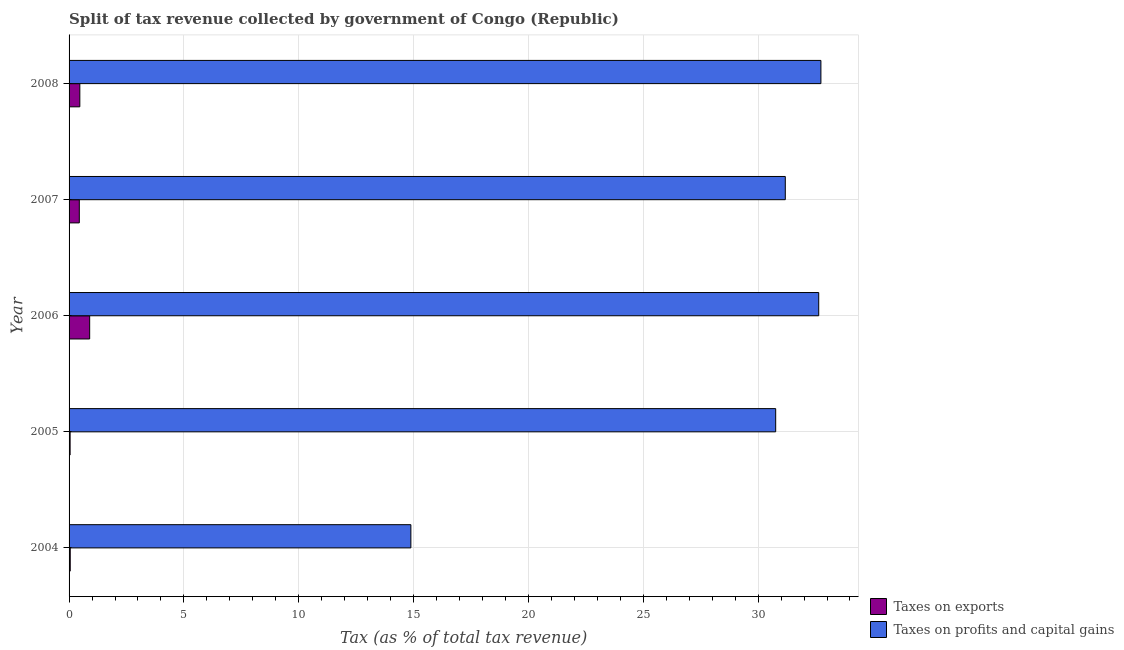How many different coloured bars are there?
Offer a very short reply. 2. Are the number of bars per tick equal to the number of legend labels?
Offer a very short reply. Yes. How many bars are there on the 4th tick from the bottom?
Provide a succinct answer. 2. What is the label of the 5th group of bars from the top?
Your response must be concise. 2004. In how many cases, is the number of bars for a given year not equal to the number of legend labels?
Offer a terse response. 0. What is the percentage of revenue obtained from taxes on exports in 2007?
Your answer should be very brief. 0.45. Across all years, what is the maximum percentage of revenue obtained from taxes on exports?
Provide a short and direct response. 0.9. Across all years, what is the minimum percentage of revenue obtained from taxes on profits and capital gains?
Offer a very short reply. 14.88. In which year was the percentage of revenue obtained from taxes on exports minimum?
Your answer should be very brief. 2005. What is the total percentage of revenue obtained from taxes on exports in the graph?
Your answer should be very brief. 1.91. What is the difference between the percentage of revenue obtained from taxes on profits and capital gains in 2005 and that in 2007?
Offer a terse response. -0.42. What is the difference between the percentage of revenue obtained from taxes on exports in 2007 and the percentage of revenue obtained from taxes on profits and capital gains in 2004?
Offer a very short reply. -14.44. What is the average percentage of revenue obtained from taxes on exports per year?
Give a very brief answer. 0.38. In the year 2004, what is the difference between the percentage of revenue obtained from taxes on profits and capital gains and percentage of revenue obtained from taxes on exports?
Make the answer very short. 14.83. What is the ratio of the percentage of revenue obtained from taxes on profits and capital gains in 2004 to that in 2007?
Offer a terse response. 0.48. What is the difference between the highest and the second highest percentage of revenue obtained from taxes on profits and capital gains?
Give a very brief answer. 0.1. What is the difference between the highest and the lowest percentage of revenue obtained from taxes on profits and capital gains?
Your answer should be very brief. 17.85. Is the sum of the percentage of revenue obtained from taxes on profits and capital gains in 2007 and 2008 greater than the maximum percentage of revenue obtained from taxes on exports across all years?
Keep it short and to the point. Yes. What does the 2nd bar from the top in 2006 represents?
Offer a very short reply. Taxes on exports. What does the 1st bar from the bottom in 2005 represents?
Offer a very short reply. Taxes on exports. What is the difference between two consecutive major ticks on the X-axis?
Ensure brevity in your answer.  5. Where does the legend appear in the graph?
Make the answer very short. Bottom right. How are the legend labels stacked?
Your response must be concise. Vertical. What is the title of the graph?
Your answer should be compact. Split of tax revenue collected by government of Congo (Republic). Does "Private funds" appear as one of the legend labels in the graph?
Make the answer very short. No. What is the label or title of the X-axis?
Offer a terse response. Tax (as % of total tax revenue). What is the label or title of the Y-axis?
Ensure brevity in your answer.  Year. What is the Tax (as % of total tax revenue) of Taxes on exports in 2004?
Your response must be concise. 0.05. What is the Tax (as % of total tax revenue) in Taxes on profits and capital gains in 2004?
Keep it short and to the point. 14.88. What is the Tax (as % of total tax revenue) of Taxes on exports in 2005?
Offer a terse response. 0.05. What is the Tax (as % of total tax revenue) of Taxes on profits and capital gains in 2005?
Offer a terse response. 30.77. What is the Tax (as % of total tax revenue) of Taxes on exports in 2006?
Give a very brief answer. 0.9. What is the Tax (as % of total tax revenue) of Taxes on profits and capital gains in 2006?
Provide a short and direct response. 32.64. What is the Tax (as % of total tax revenue) of Taxes on exports in 2007?
Offer a terse response. 0.45. What is the Tax (as % of total tax revenue) in Taxes on profits and capital gains in 2007?
Provide a short and direct response. 31.18. What is the Tax (as % of total tax revenue) in Taxes on exports in 2008?
Your answer should be very brief. 0.47. What is the Tax (as % of total tax revenue) in Taxes on profits and capital gains in 2008?
Provide a succinct answer. 32.73. Across all years, what is the maximum Tax (as % of total tax revenue) in Taxes on exports?
Your response must be concise. 0.9. Across all years, what is the maximum Tax (as % of total tax revenue) of Taxes on profits and capital gains?
Provide a short and direct response. 32.73. Across all years, what is the minimum Tax (as % of total tax revenue) of Taxes on exports?
Ensure brevity in your answer.  0.05. Across all years, what is the minimum Tax (as % of total tax revenue) of Taxes on profits and capital gains?
Ensure brevity in your answer.  14.88. What is the total Tax (as % of total tax revenue) of Taxes on exports in the graph?
Ensure brevity in your answer.  1.91. What is the total Tax (as % of total tax revenue) in Taxes on profits and capital gains in the graph?
Your answer should be very brief. 142.2. What is the difference between the Tax (as % of total tax revenue) of Taxes on exports in 2004 and that in 2005?
Your answer should be compact. 0.01. What is the difference between the Tax (as % of total tax revenue) of Taxes on profits and capital gains in 2004 and that in 2005?
Offer a very short reply. -15.88. What is the difference between the Tax (as % of total tax revenue) in Taxes on exports in 2004 and that in 2006?
Give a very brief answer. -0.85. What is the difference between the Tax (as % of total tax revenue) in Taxes on profits and capital gains in 2004 and that in 2006?
Keep it short and to the point. -17.76. What is the difference between the Tax (as % of total tax revenue) in Taxes on exports in 2004 and that in 2007?
Keep it short and to the point. -0.4. What is the difference between the Tax (as % of total tax revenue) of Taxes on profits and capital gains in 2004 and that in 2007?
Ensure brevity in your answer.  -16.3. What is the difference between the Tax (as % of total tax revenue) of Taxes on exports in 2004 and that in 2008?
Make the answer very short. -0.42. What is the difference between the Tax (as % of total tax revenue) in Taxes on profits and capital gains in 2004 and that in 2008?
Provide a succinct answer. -17.85. What is the difference between the Tax (as % of total tax revenue) of Taxes on exports in 2005 and that in 2006?
Your answer should be very brief. -0.85. What is the difference between the Tax (as % of total tax revenue) of Taxes on profits and capital gains in 2005 and that in 2006?
Your response must be concise. -1.87. What is the difference between the Tax (as % of total tax revenue) in Taxes on exports in 2005 and that in 2007?
Your answer should be very brief. -0.4. What is the difference between the Tax (as % of total tax revenue) in Taxes on profits and capital gains in 2005 and that in 2007?
Provide a short and direct response. -0.42. What is the difference between the Tax (as % of total tax revenue) of Taxes on exports in 2005 and that in 2008?
Provide a short and direct response. -0.42. What is the difference between the Tax (as % of total tax revenue) of Taxes on profits and capital gains in 2005 and that in 2008?
Offer a very short reply. -1.97. What is the difference between the Tax (as % of total tax revenue) in Taxes on exports in 2006 and that in 2007?
Give a very brief answer. 0.45. What is the difference between the Tax (as % of total tax revenue) of Taxes on profits and capital gains in 2006 and that in 2007?
Make the answer very short. 1.46. What is the difference between the Tax (as % of total tax revenue) of Taxes on exports in 2006 and that in 2008?
Provide a succinct answer. 0.43. What is the difference between the Tax (as % of total tax revenue) in Taxes on profits and capital gains in 2006 and that in 2008?
Provide a succinct answer. -0.09. What is the difference between the Tax (as % of total tax revenue) in Taxes on exports in 2007 and that in 2008?
Your response must be concise. -0.02. What is the difference between the Tax (as % of total tax revenue) of Taxes on profits and capital gains in 2007 and that in 2008?
Offer a terse response. -1.55. What is the difference between the Tax (as % of total tax revenue) of Taxes on exports in 2004 and the Tax (as % of total tax revenue) of Taxes on profits and capital gains in 2005?
Offer a terse response. -30.71. What is the difference between the Tax (as % of total tax revenue) in Taxes on exports in 2004 and the Tax (as % of total tax revenue) in Taxes on profits and capital gains in 2006?
Your answer should be very brief. -32.59. What is the difference between the Tax (as % of total tax revenue) in Taxes on exports in 2004 and the Tax (as % of total tax revenue) in Taxes on profits and capital gains in 2007?
Your response must be concise. -31.13. What is the difference between the Tax (as % of total tax revenue) in Taxes on exports in 2004 and the Tax (as % of total tax revenue) in Taxes on profits and capital gains in 2008?
Your answer should be compact. -32.68. What is the difference between the Tax (as % of total tax revenue) of Taxes on exports in 2005 and the Tax (as % of total tax revenue) of Taxes on profits and capital gains in 2006?
Keep it short and to the point. -32.59. What is the difference between the Tax (as % of total tax revenue) of Taxes on exports in 2005 and the Tax (as % of total tax revenue) of Taxes on profits and capital gains in 2007?
Ensure brevity in your answer.  -31.14. What is the difference between the Tax (as % of total tax revenue) in Taxes on exports in 2005 and the Tax (as % of total tax revenue) in Taxes on profits and capital gains in 2008?
Make the answer very short. -32.69. What is the difference between the Tax (as % of total tax revenue) of Taxes on exports in 2006 and the Tax (as % of total tax revenue) of Taxes on profits and capital gains in 2007?
Make the answer very short. -30.29. What is the difference between the Tax (as % of total tax revenue) of Taxes on exports in 2006 and the Tax (as % of total tax revenue) of Taxes on profits and capital gains in 2008?
Your answer should be very brief. -31.84. What is the difference between the Tax (as % of total tax revenue) of Taxes on exports in 2007 and the Tax (as % of total tax revenue) of Taxes on profits and capital gains in 2008?
Your answer should be very brief. -32.29. What is the average Tax (as % of total tax revenue) in Taxes on exports per year?
Offer a very short reply. 0.38. What is the average Tax (as % of total tax revenue) of Taxes on profits and capital gains per year?
Provide a short and direct response. 28.44. In the year 2004, what is the difference between the Tax (as % of total tax revenue) in Taxes on exports and Tax (as % of total tax revenue) in Taxes on profits and capital gains?
Give a very brief answer. -14.83. In the year 2005, what is the difference between the Tax (as % of total tax revenue) of Taxes on exports and Tax (as % of total tax revenue) of Taxes on profits and capital gains?
Provide a short and direct response. -30.72. In the year 2006, what is the difference between the Tax (as % of total tax revenue) in Taxes on exports and Tax (as % of total tax revenue) in Taxes on profits and capital gains?
Provide a short and direct response. -31.74. In the year 2007, what is the difference between the Tax (as % of total tax revenue) of Taxes on exports and Tax (as % of total tax revenue) of Taxes on profits and capital gains?
Ensure brevity in your answer.  -30.74. In the year 2008, what is the difference between the Tax (as % of total tax revenue) in Taxes on exports and Tax (as % of total tax revenue) in Taxes on profits and capital gains?
Your answer should be very brief. -32.27. What is the ratio of the Tax (as % of total tax revenue) of Taxes on exports in 2004 to that in 2005?
Make the answer very short. 1.11. What is the ratio of the Tax (as % of total tax revenue) in Taxes on profits and capital gains in 2004 to that in 2005?
Offer a very short reply. 0.48. What is the ratio of the Tax (as % of total tax revenue) of Taxes on exports in 2004 to that in 2006?
Your answer should be very brief. 0.06. What is the ratio of the Tax (as % of total tax revenue) of Taxes on profits and capital gains in 2004 to that in 2006?
Keep it short and to the point. 0.46. What is the ratio of the Tax (as % of total tax revenue) in Taxes on exports in 2004 to that in 2007?
Provide a short and direct response. 0.11. What is the ratio of the Tax (as % of total tax revenue) in Taxes on profits and capital gains in 2004 to that in 2007?
Your answer should be very brief. 0.48. What is the ratio of the Tax (as % of total tax revenue) of Taxes on exports in 2004 to that in 2008?
Your answer should be very brief. 0.11. What is the ratio of the Tax (as % of total tax revenue) of Taxes on profits and capital gains in 2004 to that in 2008?
Offer a very short reply. 0.45. What is the ratio of the Tax (as % of total tax revenue) of Taxes on exports in 2005 to that in 2006?
Keep it short and to the point. 0.05. What is the ratio of the Tax (as % of total tax revenue) of Taxes on profits and capital gains in 2005 to that in 2006?
Offer a very short reply. 0.94. What is the ratio of the Tax (as % of total tax revenue) of Taxes on exports in 2005 to that in 2007?
Ensure brevity in your answer.  0.1. What is the ratio of the Tax (as % of total tax revenue) in Taxes on profits and capital gains in 2005 to that in 2007?
Your answer should be compact. 0.99. What is the ratio of the Tax (as % of total tax revenue) in Taxes on exports in 2005 to that in 2008?
Offer a terse response. 0.1. What is the ratio of the Tax (as % of total tax revenue) of Taxes on profits and capital gains in 2005 to that in 2008?
Offer a terse response. 0.94. What is the ratio of the Tax (as % of total tax revenue) of Taxes on exports in 2006 to that in 2007?
Give a very brief answer. 2.01. What is the ratio of the Tax (as % of total tax revenue) of Taxes on profits and capital gains in 2006 to that in 2007?
Make the answer very short. 1.05. What is the ratio of the Tax (as % of total tax revenue) in Taxes on exports in 2006 to that in 2008?
Your response must be concise. 1.92. What is the ratio of the Tax (as % of total tax revenue) of Taxes on exports in 2007 to that in 2008?
Provide a succinct answer. 0.95. What is the ratio of the Tax (as % of total tax revenue) of Taxes on profits and capital gains in 2007 to that in 2008?
Your answer should be very brief. 0.95. What is the difference between the highest and the second highest Tax (as % of total tax revenue) in Taxes on exports?
Your response must be concise. 0.43. What is the difference between the highest and the second highest Tax (as % of total tax revenue) in Taxes on profits and capital gains?
Provide a short and direct response. 0.09. What is the difference between the highest and the lowest Tax (as % of total tax revenue) of Taxes on exports?
Your response must be concise. 0.85. What is the difference between the highest and the lowest Tax (as % of total tax revenue) of Taxes on profits and capital gains?
Give a very brief answer. 17.85. 